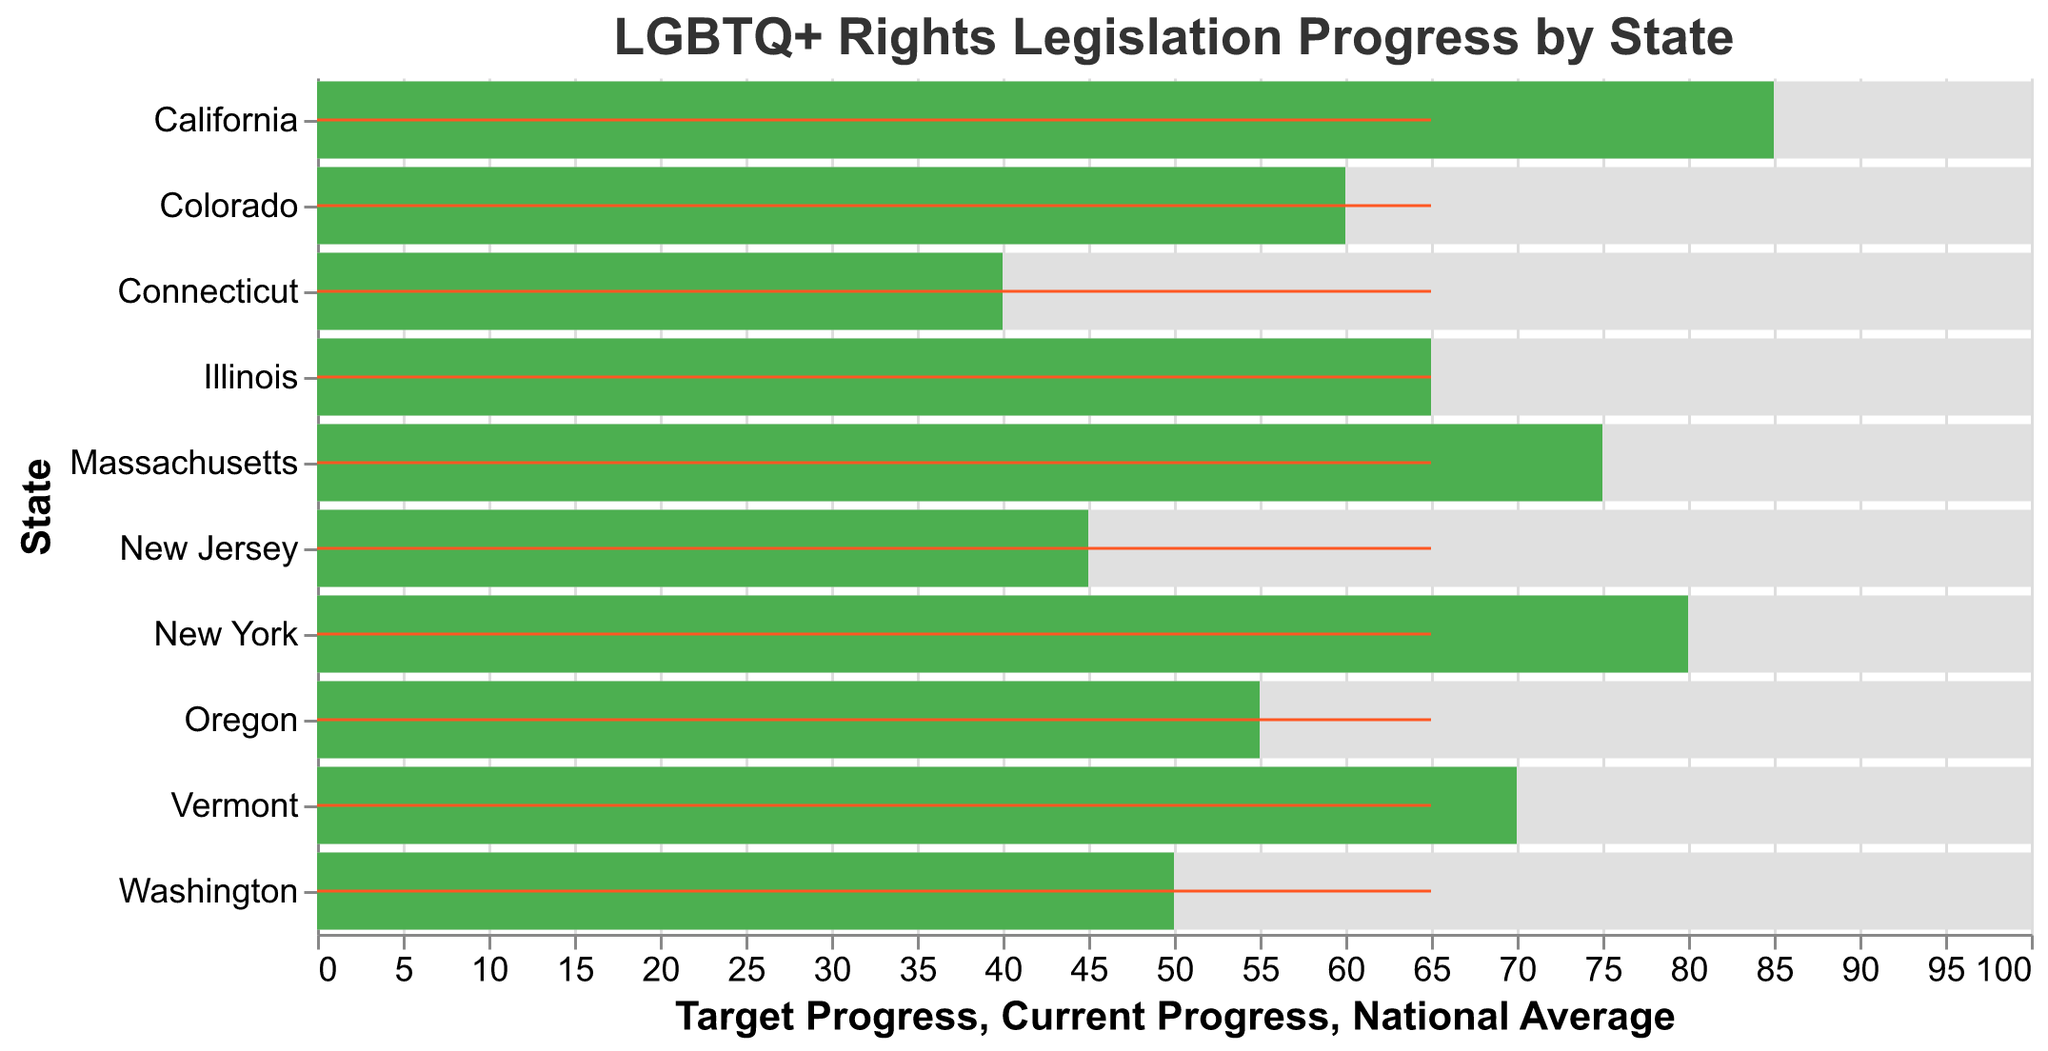What is the title of the chart? The title is located at the top of the chart. It reads "LGBTQ+ Rights Legislation Progress by State".
Answer: LGBTQ+ Rights Legislation Progress by State Which state has the highest current progress? By looking at the "Current Progress" bar, you can see that the longest bar represents California.
Answer: California What is the national average progress? There is a red vertical line representing the "National Average" on all states, with a tooltip indicating the value is 65.
Answer: 65 How much progress has Oregon made towards the target? The "Current Progress" bar for Oregon indicates it is at 55, whereas the "Target Progress" bar reaches 100.
Answer: 55 Identify the states with a current progress below the national average. By examining the "Current Progress" bars relative to the "National Average" line, Connecticut, New Jersey, and Washington fall below 65.
Answer: Connecticut, New Jersey, Washington What is the difference in current progress between the state with the highest and the state with the lowest progress? California has the highest "Current Progress" at 85, and Connecticut has the lowest at 40. The difference is 85 - 40.
Answer: 45 Which states have achieved more than 70% of their target progress? States where the green "Current Progress" bar is at least 70. California, New York, and Massachusetts have met this criterion.
Answer: California, New York, Massachusetts What percentage of the target has Illinois achieved? Illinois's "Current Progress" is 65 and the "Target Progress" is 100. The percentage is (65/100) * 100%.
Answer: 65% How does the current progress of Colorado compare to Washington? Colorado’s "Current Progress" bar shows 60, whereas Washington’s "Current Progress" is 50.
Answer: Colorado has made more progress than Washington Which state is closest to the national average in terms of current progress? Illinois's "Current Progress" at 65 closely matches the "National Average" of 65, indicated by the overlapping of the green bar and the red line.
Answer: Illinois 